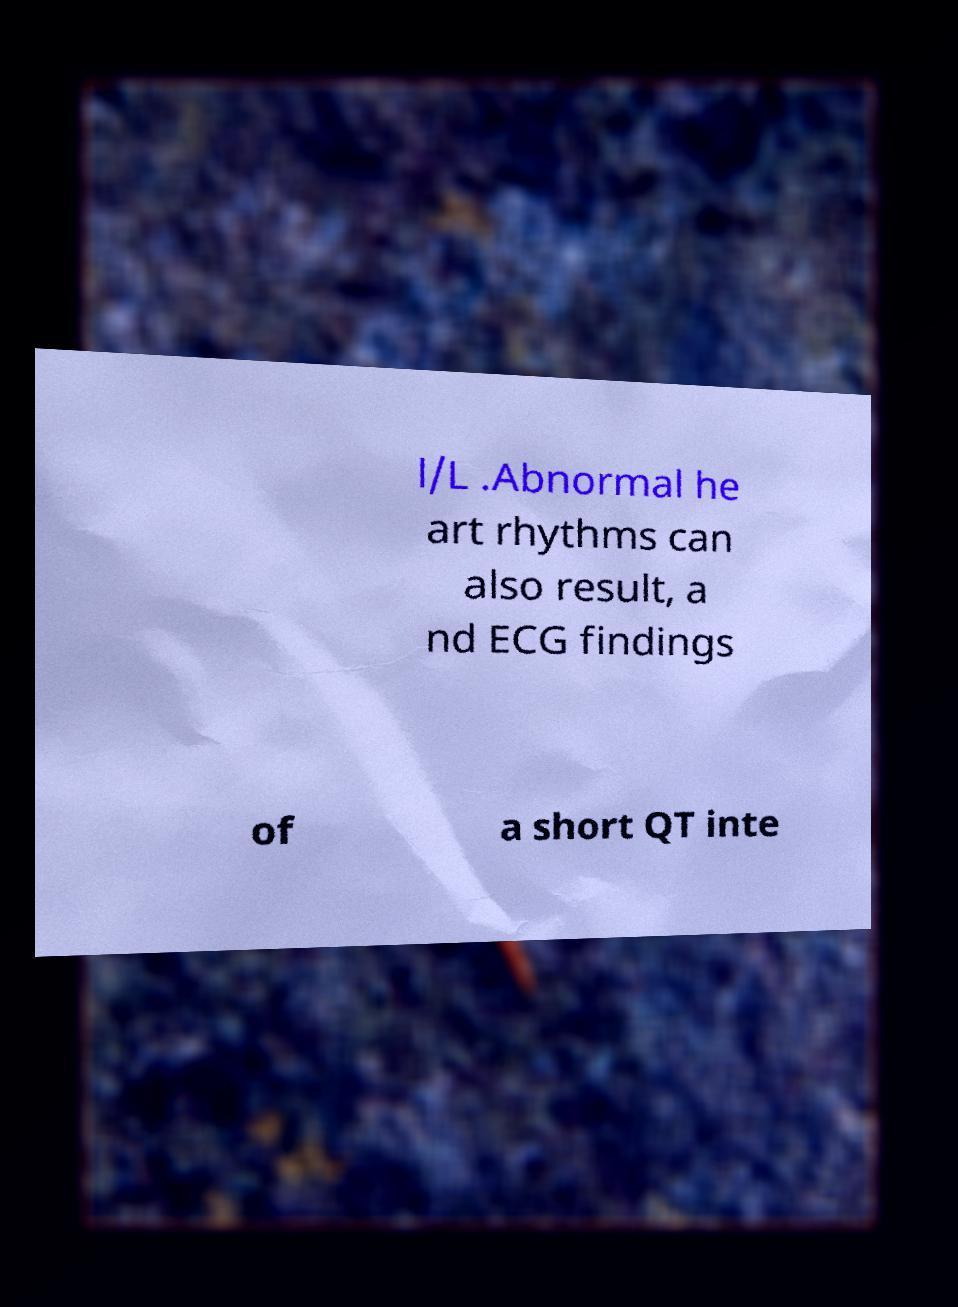There's text embedded in this image that I need extracted. Can you transcribe it verbatim? l/L .Abnormal he art rhythms can also result, a nd ECG findings of a short QT inte 